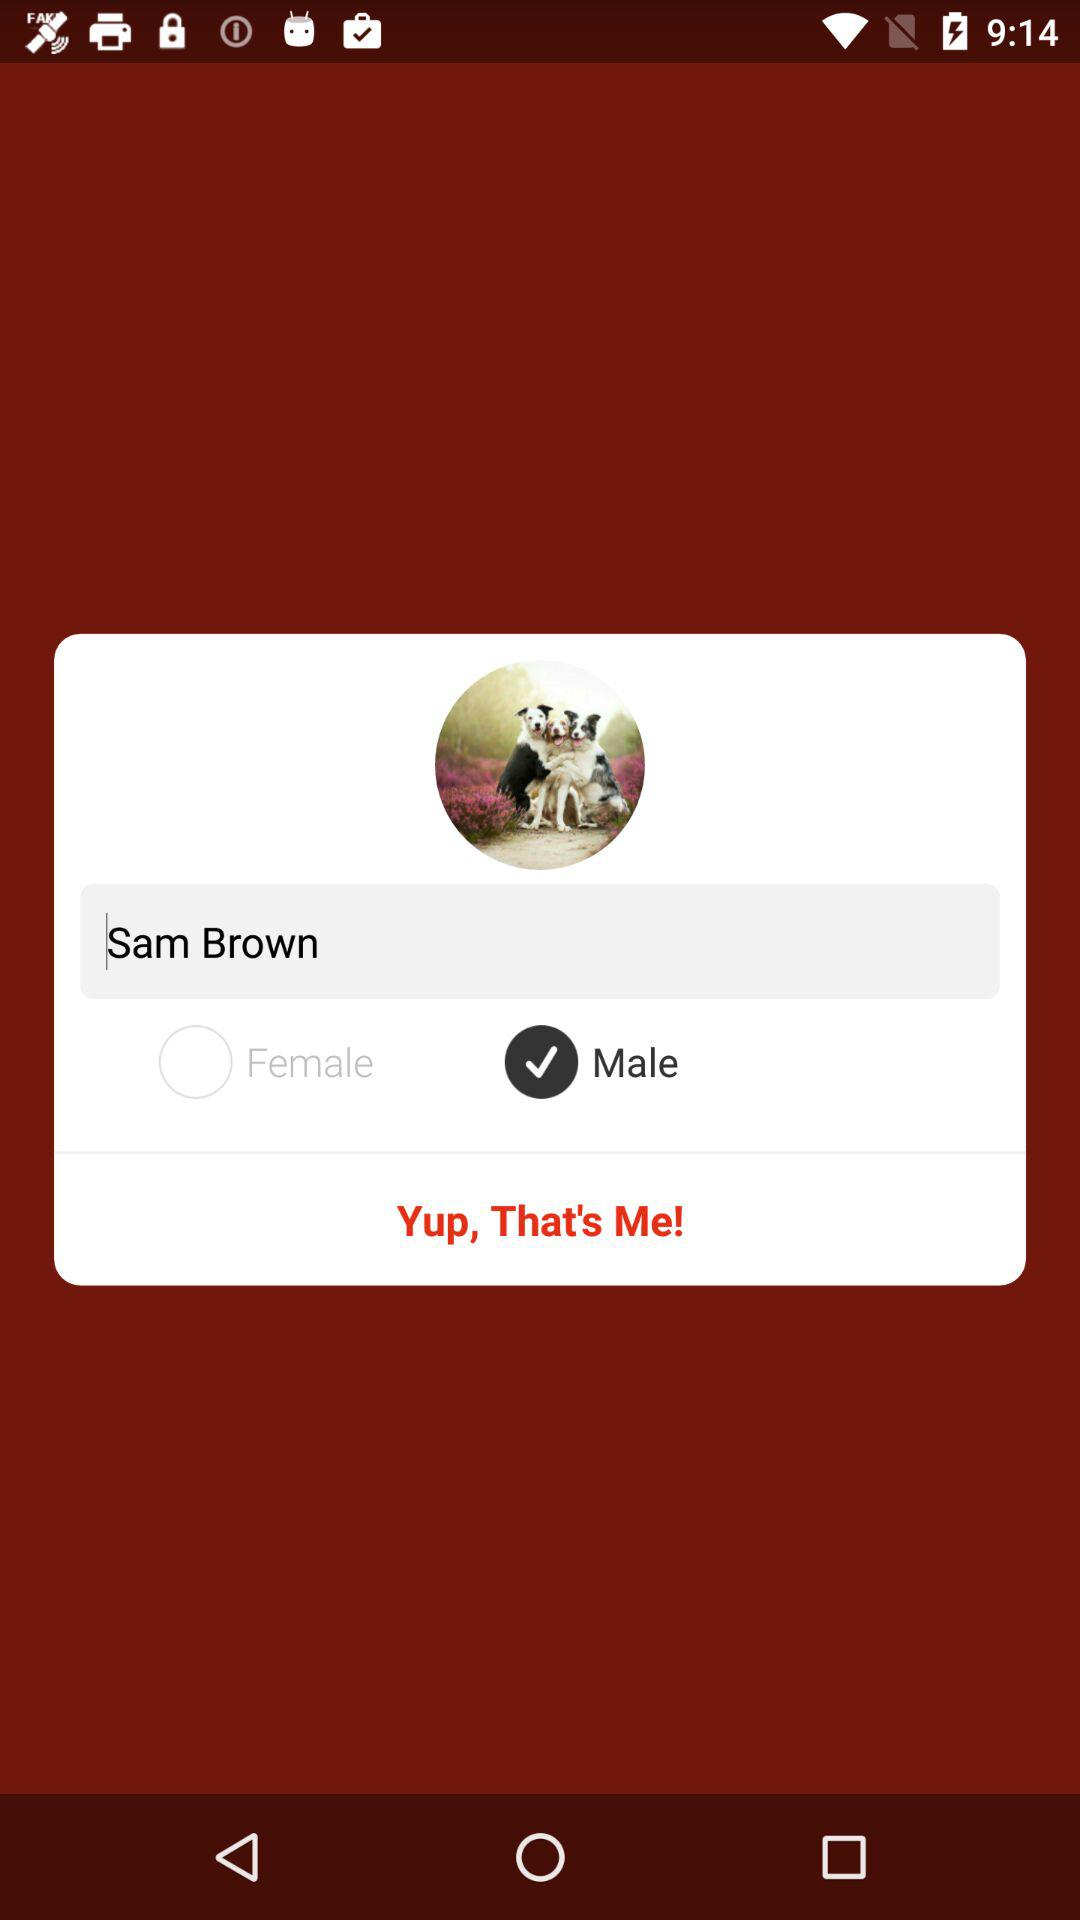What is the gender? The gender is male. 